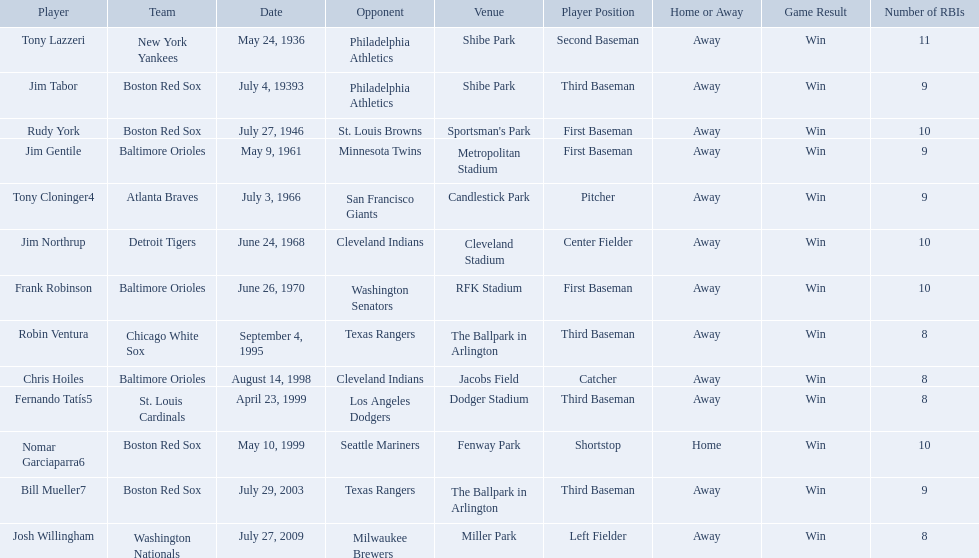What venue did detroit play cleveland in? Cleveland Stadium. Who was the player? Jim Northrup. What date did they play? June 24, 1968. What were the dates of each game? May 24, 1936, July 4, 19393, July 27, 1946, May 9, 1961, July 3, 1966, June 24, 1968, June 26, 1970, September 4, 1995, August 14, 1998, April 23, 1999, May 10, 1999, July 29, 2003, July 27, 2009. Who were all of the teams? New York Yankees, Boston Red Sox, Boston Red Sox, Baltimore Orioles, Atlanta Braves, Detroit Tigers, Baltimore Orioles, Chicago White Sox, Baltimore Orioles, St. Louis Cardinals, Boston Red Sox, Boston Red Sox, Washington Nationals. What about their opponents? Philadelphia Athletics, Philadelphia Athletics, St. Louis Browns, Minnesota Twins, San Francisco Giants, Cleveland Indians, Washington Senators, Texas Rangers, Cleveland Indians, Los Angeles Dodgers, Seattle Mariners, Texas Rangers, Milwaukee Brewers. And on which date did the detroit tigers play against the cleveland indians? June 24, 1968. Which teams played between the years 1960 and 1970? Baltimore Orioles, Atlanta Braves, Detroit Tigers, Baltimore Orioles. Of these teams that played, which ones played against the cleveland indians? Detroit Tigers. On what day did these two teams play? June 24, 1968. Who are all the opponents? Philadelphia Athletics, Philadelphia Athletics, St. Louis Browns, Minnesota Twins, San Francisco Giants, Cleveland Indians, Washington Senators, Texas Rangers, Cleveland Indians, Los Angeles Dodgers, Seattle Mariners, Texas Rangers, Milwaukee Brewers. What teams played on july 27, 1946? Boston Red Sox, July 27, 1946, St. Louis Browns. Who was the opponent in this game? St. Louis Browns. What are the dates? May 24, 1936, July 4, 19393, July 27, 1946, May 9, 1961, July 3, 1966, June 24, 1968, June 26, 1970, September 4, 1995, August 14, 1998, April 23, 1999, May 10, 1999, July 29, 2003, July 27, 2009. Which date is in 1936? May 24, 1936. What player is listed for this date? Tony Lazzeri. 